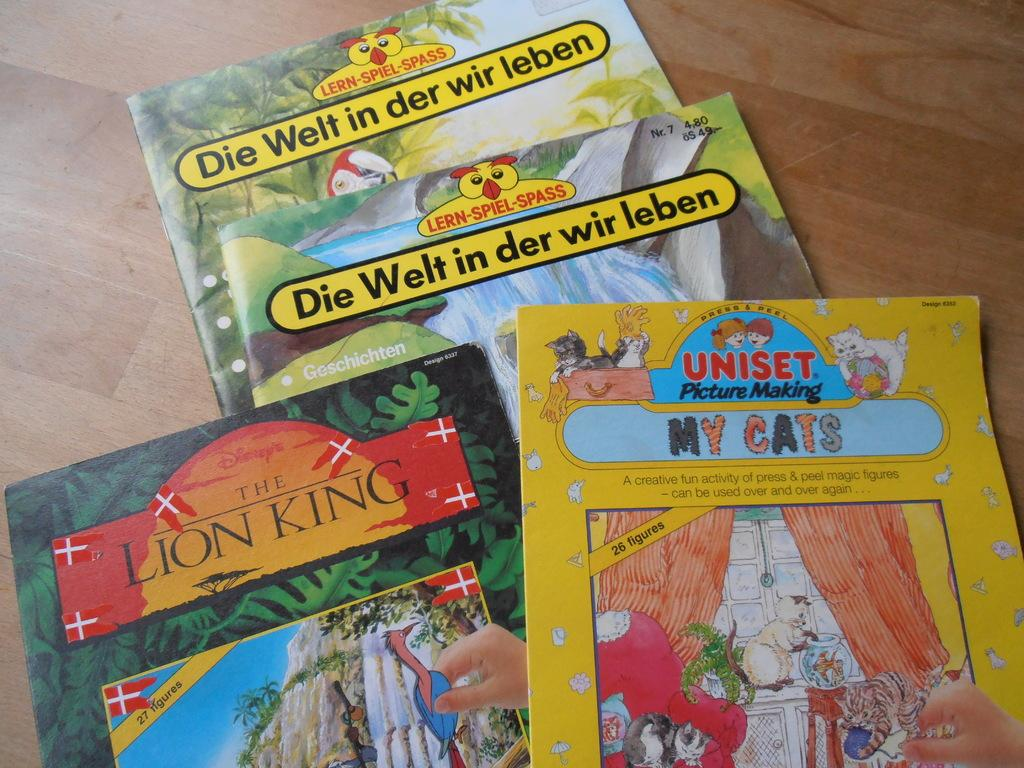<image>
Render a clear and concise summary of the photo. A collection of children's books, including The Lion King and My Cats. 